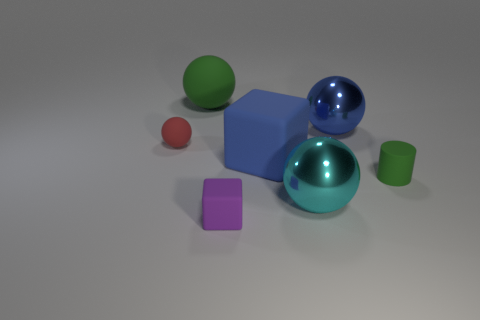How many red balls are the same size as the cyan ball?
Your answer should be compact. 0. How many shiny objects are cyan things or big blue blocks?
Give a very brief answer. 1. The ball that is the same color as the large cube is what size?
Offer a very short reply. Large. What is the large blue object that is behind the tiny thing that is behind the green matte cylinder made of?
Make the answer very short. Metal. How many things are large rubber blocks or metallic spheres that are behind the large blue matte cube?
Offer a terse response. 2. There is another object that is the same material as the cyan thing; what is its size?
Ensure brevity in your answer.  Large. How many brown things are small matte balls or rubber cylinders?
Your answer should be compact. 0. What is the shape of the large metal thing that is the same color as the large block?
Ensure brevity in your answer.  Sphere. Is the shape of the big shiny thing to the left of the blue metal sphere the same as the big blue object to the right of the large cyan metal object?
Offer a very short reply. Yes. How many big blue rubber objects are there?
Offer a terse response. 1. 